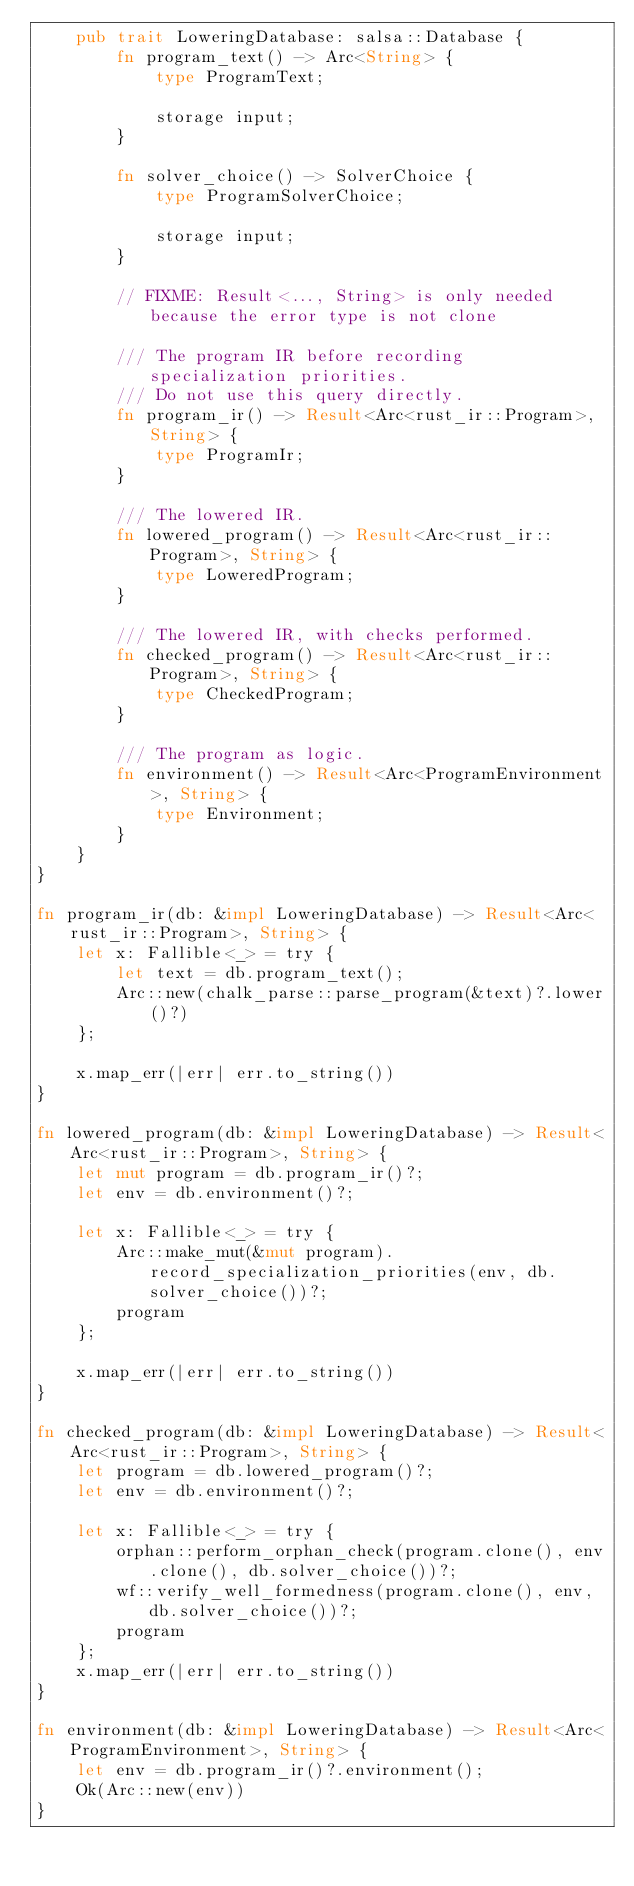<code> <loc_0><loc_0><loc_500><loc_500><_Rust_>    pub trait LoweringDatabase: salsa::Database {
        fn program_text() -> Arc<String> {
            type ProgramText;

            storage input;
        }

        fn solver_choice() -> SolverChoice {
            type ProgramSolverChoice;

            storage input;
        }

        // FIXME: Result<..., String> is only needed because the error type is not clone

        /// The program IR before recording specialization priorities.
        /// Do not use this query directly.
        fn program_ir() -> Result<Arc<rust_ir::Program>, String> {
            type ProgramIr;
        }

        /// The lowered IR.
        fn lowered_program() -> Result<Arc<rust_ir::Program>, String> {
            type LoweredProgram;
        }

        /// The lowered IR, with checks performed.
        fn checked_program() -> Result<Arc<rust_ir::Program>, String> {
            type CheckedProgram;
        }

        /// The program as logic.
        fn environment() -> Result<Arc<ProgramEnvironment>, String> {
            type Environment;
        }
    }
}

fn program_ir(db: &impl LoweringDatabase) -> Result<Arc<rust_ir::Program>, String> {
    let x: Fallible<_> = try {
        let text = db.program_text();
        Arc::new(chalk_parse::parse_program(&text)?.lower()?)
    };

    x.map_err(|err| err.to_string())
}

fn lowered_program(db: &impl LoweringDatabase) -> Result<Arc<rust_ir::Program>, String> {
    let mut program = db.program_ir()?;
    let env = db.environment()?;

    let x: Fallible<_> = try {
        Arc::make_mut(&mut program).record_specialization_priorities(env, db.solver_choice())?;
        program
    };

    x.map_err(|err| err.to_string())
}

fn checked_program(db: &impl LoweringDatabase) -> Result<Arc<rust_ir::Program>, String> {
    let program = db.lowered_program()?;
    let env = db.environment()?;

    let x: Fallible<_> = try {
        orphan::perform_orphan_check(program.clone(), env.clone(), db.solver_choice())?;
        wf::verify_well_formedness(program.clone(), env, db.solver_choice())?;
        program
    };
    x.map_err(|err| err.to_string())
}

fn environment(db: &impl LoweringDatabase) -> Result<Arc<ProgramEnvironment>, String> {
    let env = db.program_ir()?.environment();
    Ok(Arc::new(env))
}
</code> 